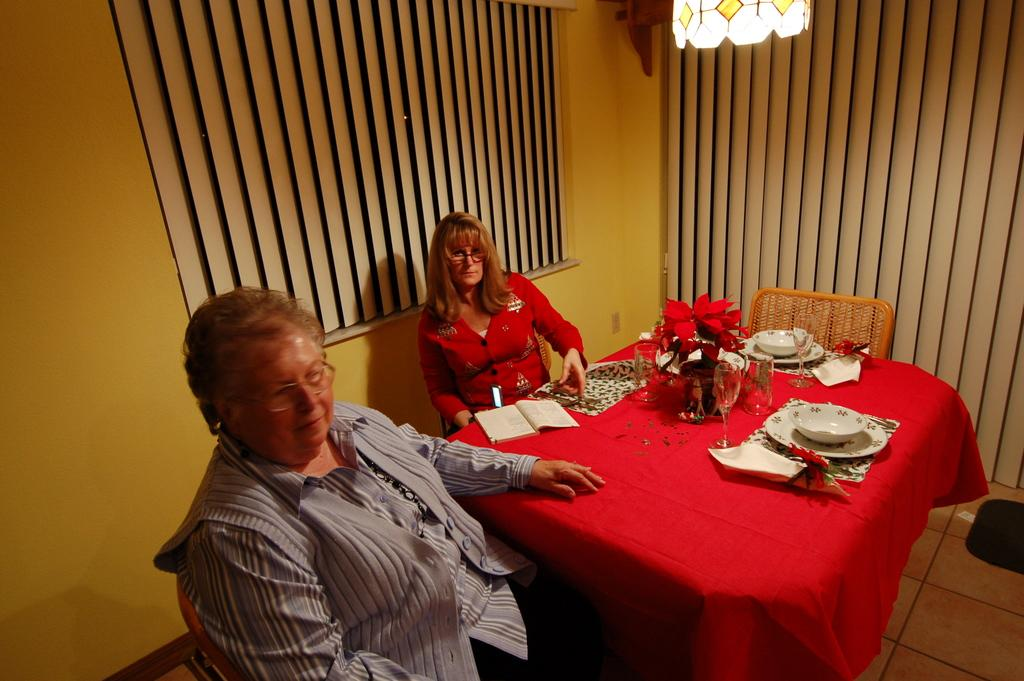How many people are in the image? There are two people in the image. What are the people doing in the image? The people are sitting on chairs. What is in front of the people? There is a table in front of the people. What items can be seen on the table? There is a bowl and a plate on the table. What type of feather can be seen on the plate in the image? There is no feather present on the plate in the image. What is being mined in the image? There is no mining activity depicted in the image. 